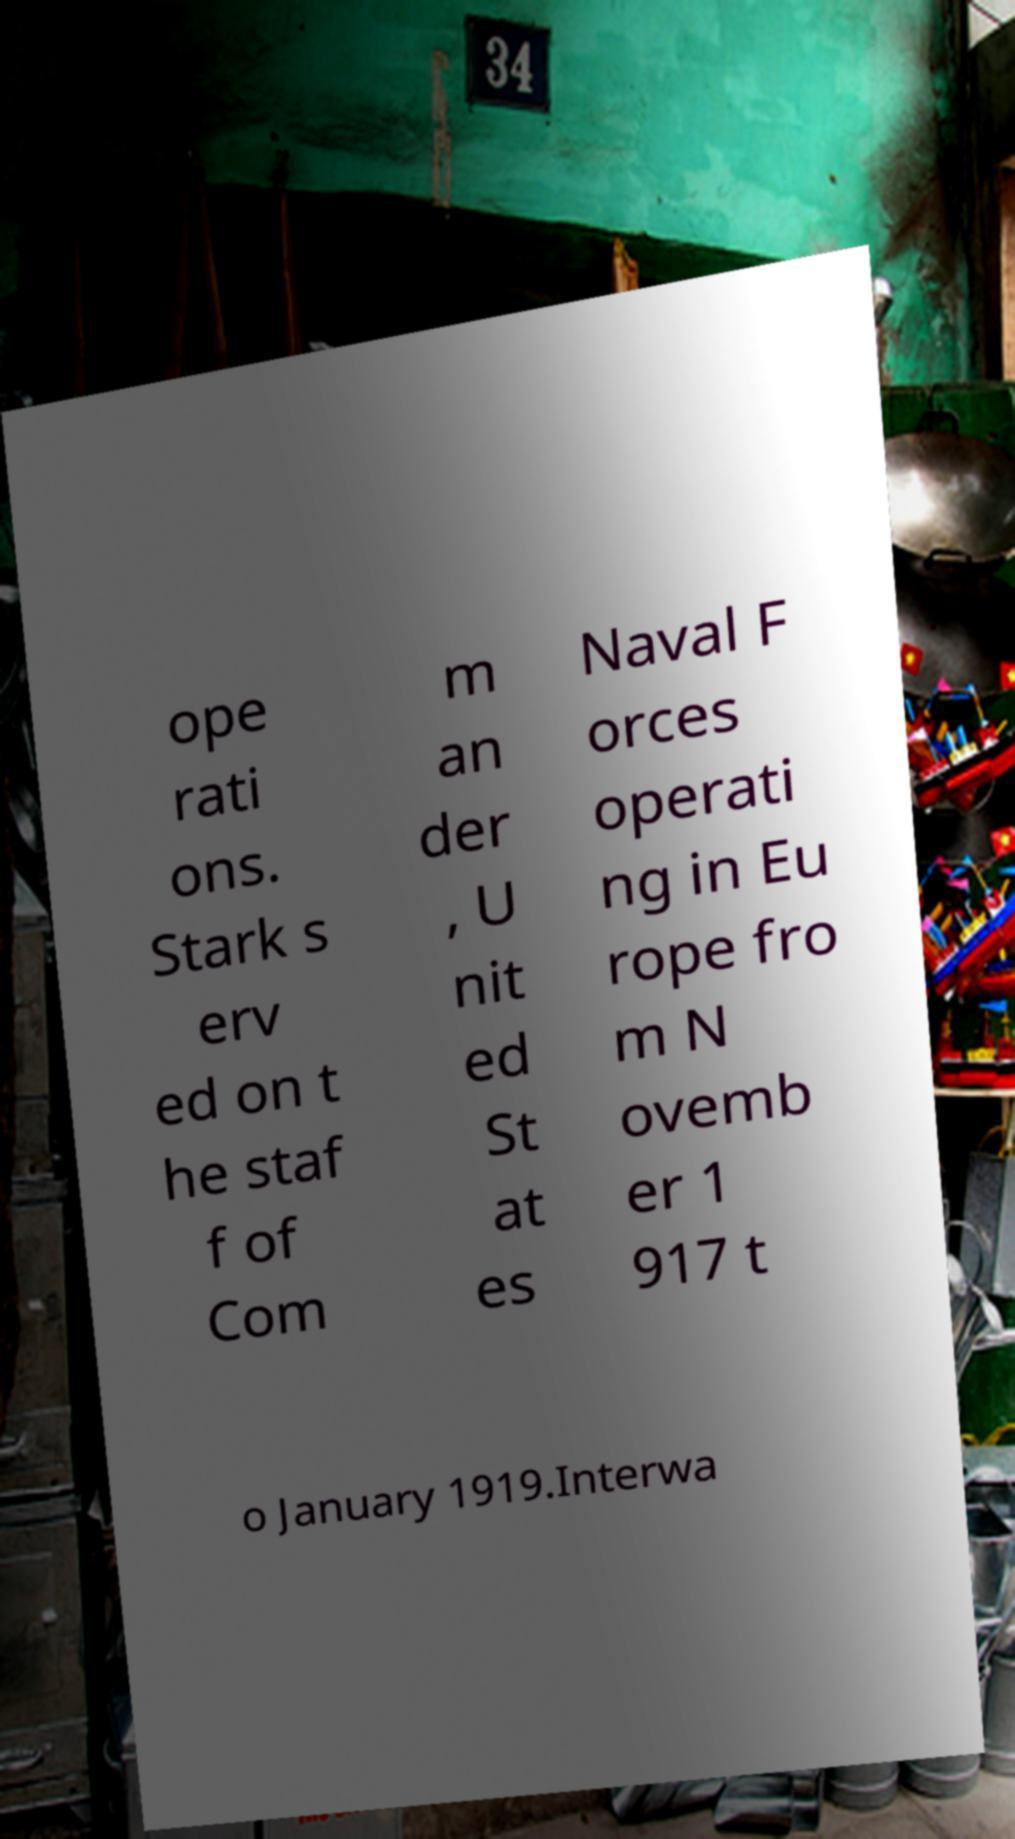There's text embedded in this image that I need extracted. Can you transcribe it verbatim? ope rati ons. Stark s erv ed on t he staf f of Com m an der , U nit ed St at es Naval F orces operati ng in Eu rope fro m N ovemb er 1 917 t o January 1919.Interwa 